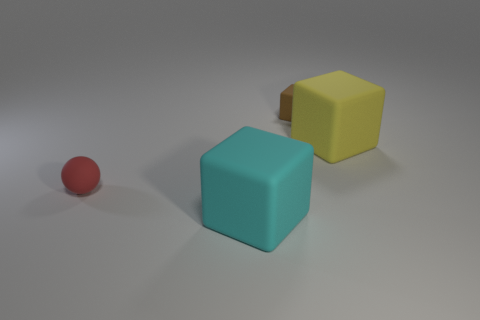Subtract all big blocks. How many blocks are left? 1 Add 4 gray rubber blocks. How many objects exist? 8 Subtract all brown blocks. How many blocks are left? 2 Subtract all cubes. How many objects are left? 1 Add 1 small brown matte objects. How many small brown matte objects exist? 2 Subtract 0 blue blocks. How many objects are left? 4 Subtract all green spheres. Subtract all green cubes. How many spheres are left? 1 Subtract all tiny brown things. Subtract all red spheres. How many objects are left? 2 Add 2 red spheres. How many red spheres are left? 3 